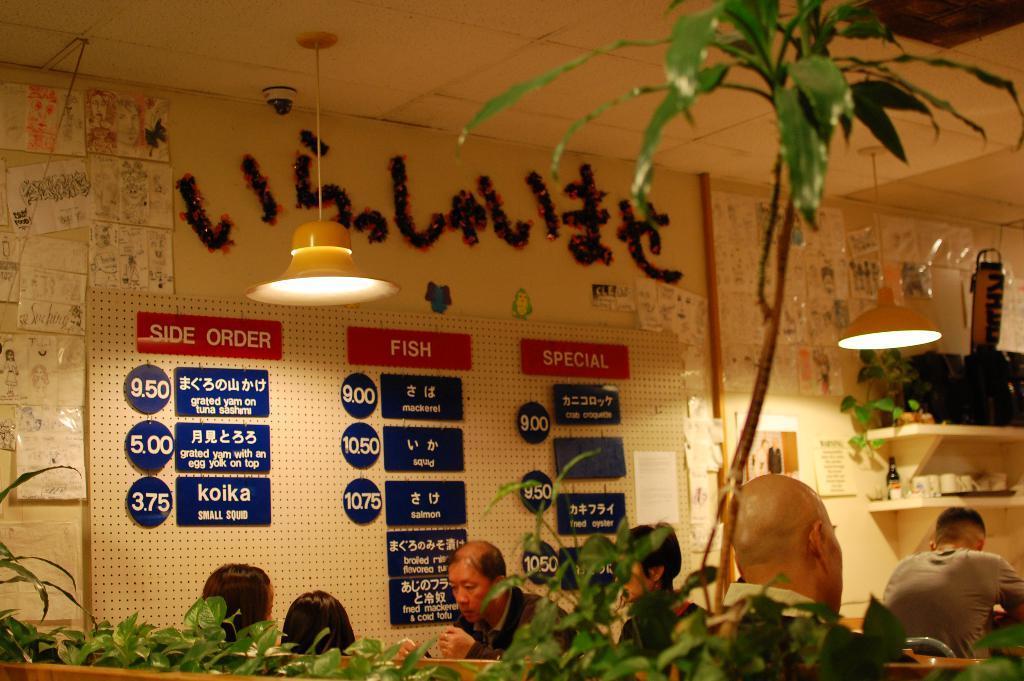Can you describe this image briefly? In this image we can see some persons, lights and other objects. At the bottom of the image there are some plants. In the background of the image there is a wall, name boards, plants and some other objects. At the top of the image there is the ceiling. 